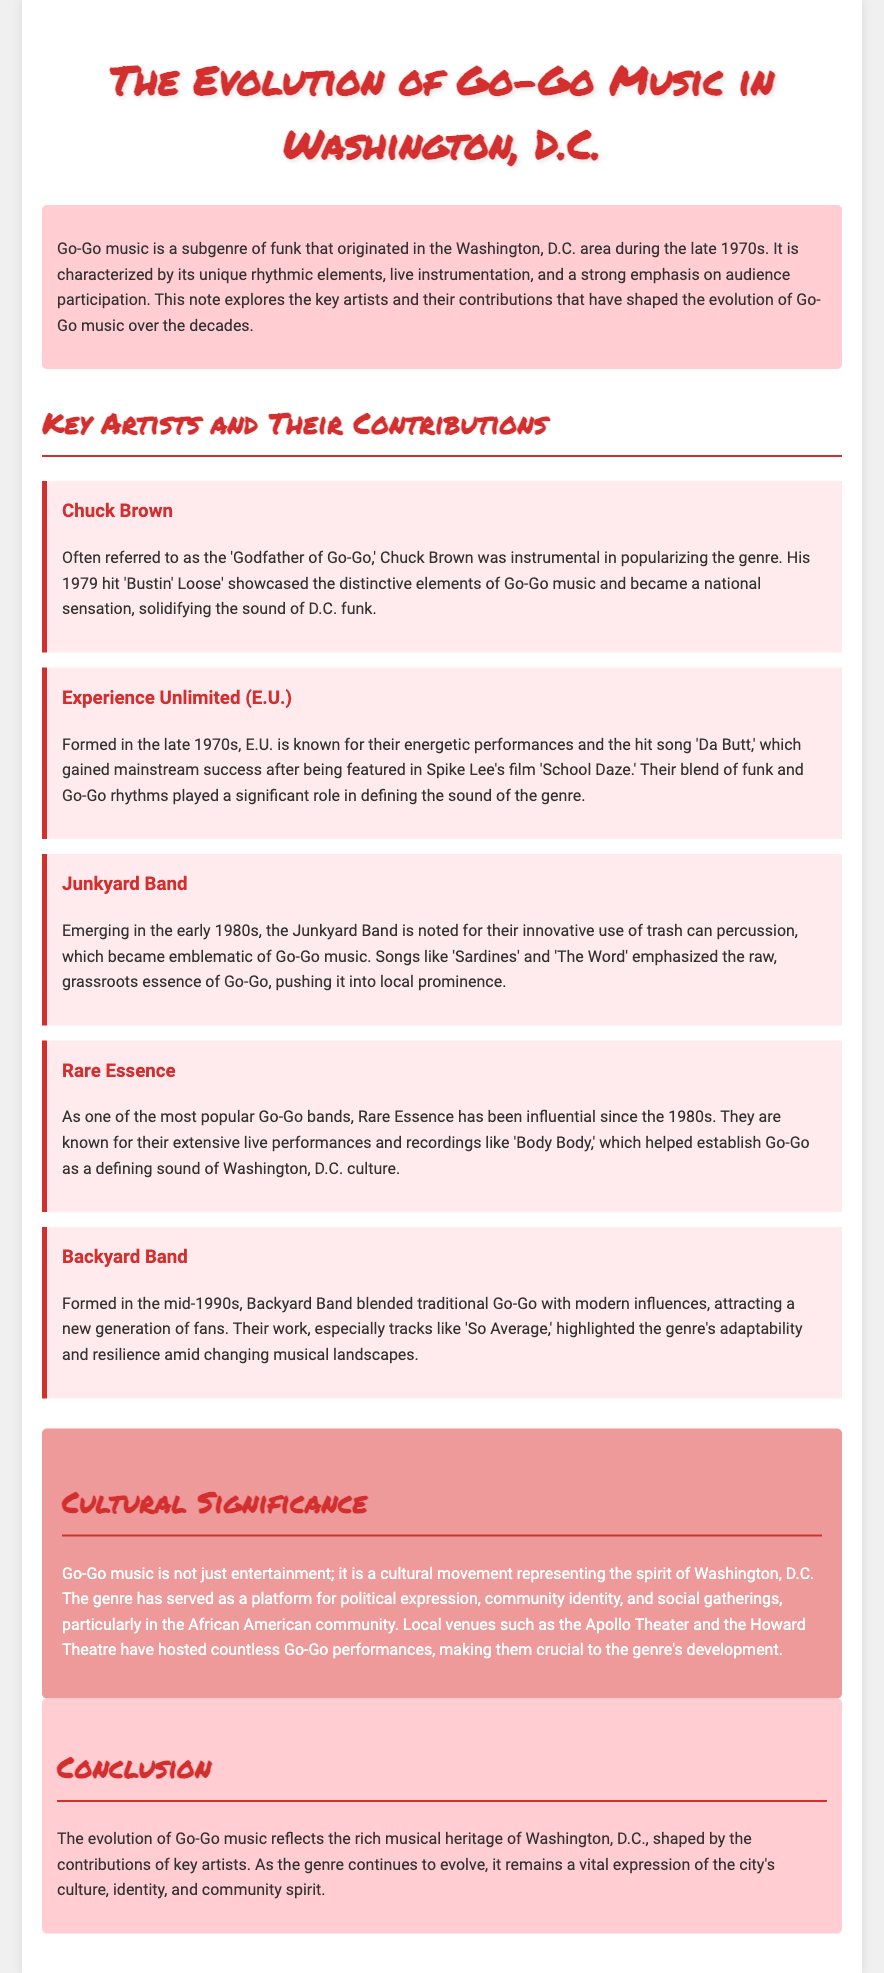What genre did Go-Go music originate from? Go-Go music is a subgenre of funk that originated in the Washington, D.C. area.
Answer: funk Who is referred to as the 'Godfather of Go-Go'? The document mentions Chuck Brown as the 'Godfather of Go-Go.'
Answer: Chuck Brown What is the title of the hit song by Experience Unlimited featured in 'School Daze'? The document states the hit song by Experience Unlimited is 'Da Butt.'
Answer: Da Butt In what decade did the Junkyard Band emerge? The document indicates that the Junkyard Band emerged in the early 1980s.
Answer: 1980s Which song by Rare Essence is mentioned as helping establish Go-Go in D.C.? The document identifies 'Body Body' as a significant song by Rare Essence.
Answer: Body Body What type of percussion is associated with the Junkyard Band? The document describes the Junkyard Band's use of trash can percussion as emblematic of Go-Go music.
Answer: trash can percussion How did Backyard Band contribute to the evolution of Go-Go? The document notes that Backyard Band blended traditional Go-Go with modern influences, attracting a new generation of fans.
Answer: blended traditional with modern What does Go-Go music represent in Washington, D.C.? The document states that Go-Go music represents the spirit of Washington, D.C. and serves as a platform for political expression and community identity.
Answer: cultural movement What venues are mentioned as significant to the Go-Go genre? The document mentions the Apollo Theater and the Howard Theatre as crucial venues for Go-Go performances.
Answer: Apollo Theater, Howard Theatre What year was 'Bustin' Loose' released? The document does not specify the exact year of the release; it simply states it was a 1979 hit.
Answer: 1979 